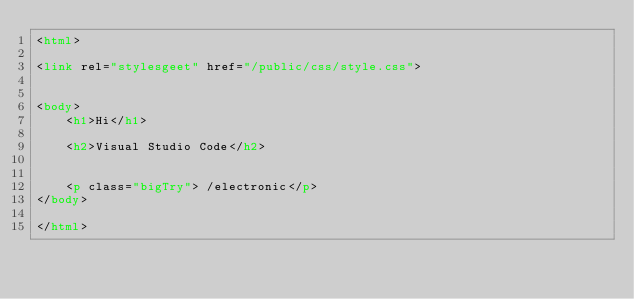<code> <loc_0><loc_0><loc_500><loc_500><_HTML_><html>

<link rel="stylesgeet" href="/public/css/style.css">


<body>
    <h1>Hi</h1>

    <h2>Visual Studio Code</h2>


    <p class="bigTry"> /electronic</p>
</body>

</html></code> 